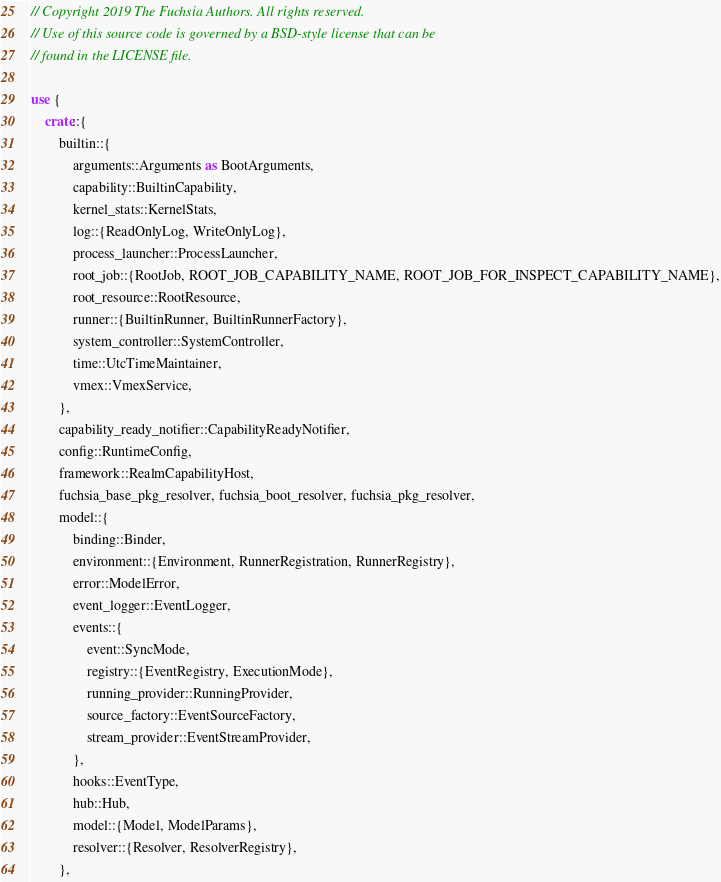<code> <loc_0><loc_0><loc_500><loc_500><_Rust_>// Copyright 2019 The Fuchsia Authors. All rights reserved.
// Use of this source code is governed by a BSD-style license that can be
// found in the LICENSE file.

use {
    crate::{
        builtin::{
            arguments::Arguments as BootArguments,
            capability::BuiltinCapability,
            kernel_stats::KernelStats,
            log::{ReadOnlyLog, WriteOnlyLog},
            process_launcher::ProcessLauncher,
            root_job::{RootJob, ROOT_JOB_CAPABILITY_NAME, ROOT_JOB_FOR_INSPECT_CAPABILITY_NAME},
            root_resource::RootResource,
            runner::{BuiltinRunner, BuiltinRunnerFactory},
            system_controller::SystemController,
            time::UtcTimeMaintainer,
            vmex::VmexService,
        },
        capability_ready_notifier::CapabilityReadyNotifier,
        config::RuntimeConfig,
        framework::RealmCapabilityHost,
        fuchsia_base_pkg_resolver, fuchsia_boot_resolver, fuchsia_pkg_resolver,
        model::{
            binding::Binder,
            environment::{Environment, RunnerRegistration, RunnerRegistry},
            error::ModelError,
            event_logger::EventLogger,
            events::{
                event::SyncMode,
                registry::{EventRegistry, ExecutionMode},
                running_provider::RunningProvider,
                source_factory::EventSourceFactory,
                stream_provider::EventStreamProvider,
            },
            hooks::EventType,
            hub::Hub,
            model::{Model, ModelParams},
            resolver::{Resolver, ResolverRegistry},
        },</code> 